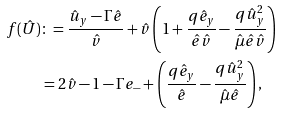Convert formula to latex. <formula><loc_0><loc_0><loc_500><loc_500>f ( \hat { U } ) & \colon = \frac { \hat { u } _ { y } - \Gamma \hat { e } } { \hat { v } } + \hat { v } \left ( 1 + \frac { q \hat { e } _ { y } } { \hat { e } \hat { v } } - \frac { q \hat { u } _ { y } ^ { 2 } } { \hat { \mu } \hat { e } \hat { v } } \right ) \\ & = 2 \hat { v } - 1 - \Gamma e _ { - } + \left ( \frac { q \hat { e } _ { y } } { \hat { e } } - \frac { q \hat { u } _ { y } ^ { 2 } } { \hat { \mu } \hat { e } } \right ) ,</formula> 